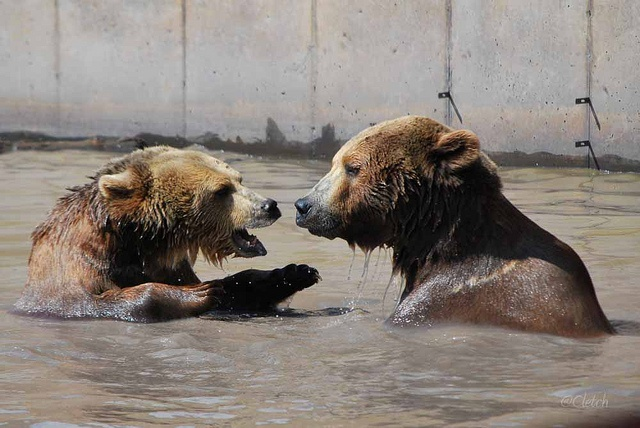Describe the objects in this image and their specific colors. I can see bear in darkgray, black, gray, and maroon tones and bear in darkgray, black, and gray tones in this image. 